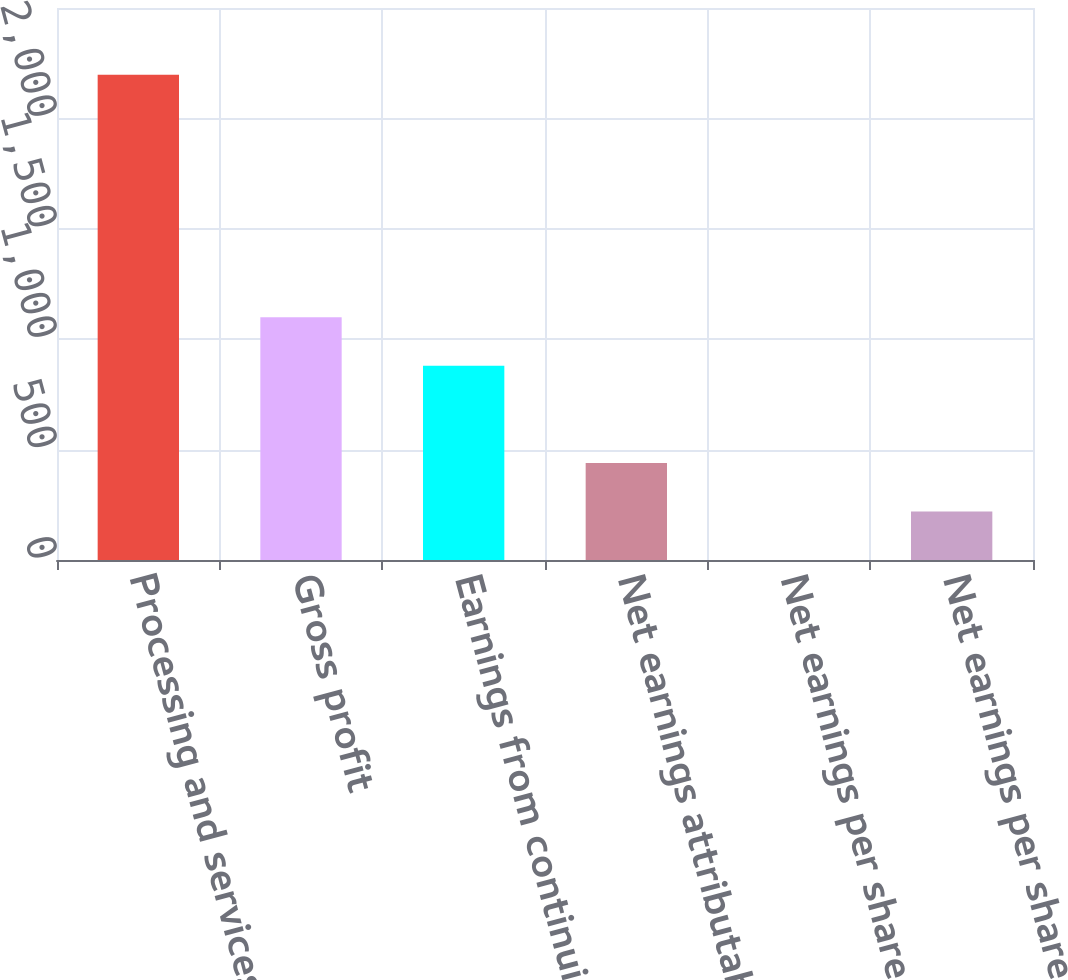Convert chart. <chart><loc_0><loc_0><loc_500><loc_500><bar_chart><fcel>Processing and services<fcel>Gross profit<fcel>Earnings from continuing<fcel>Net earnings attributable to<fcel>Net earnings per share - basic<fcel>Net earnings per share -<nl><fcel>2198<fcel>1099.08<fcel>879.3<fcel>439.74<fcel>0.18<fcel>219.96<nl></chart> 